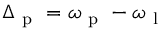<formula> <loc_0><loc_0><loc_500><loc_500>\Delta _ { p } = \omega _ { p } - \omega _ { l }</formula> 